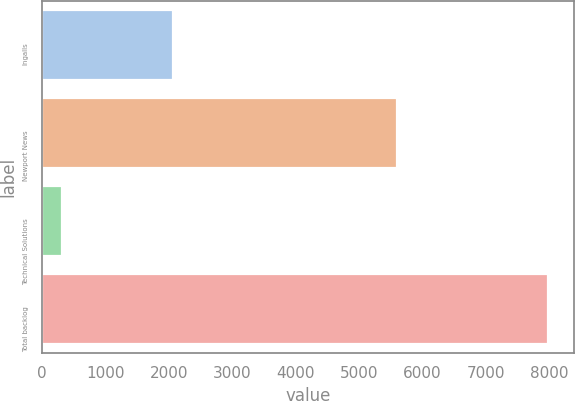<chart> <loc_0><loc_0><loc_500><loc_500><bar_chart><fcel>Ingalls<fcel>Newport News<fcel>Technical Solutions<fcel>Total backlog<nl><fcel>2071<fcel>5608<fcel>314<fcel>7993<nl></chart> 